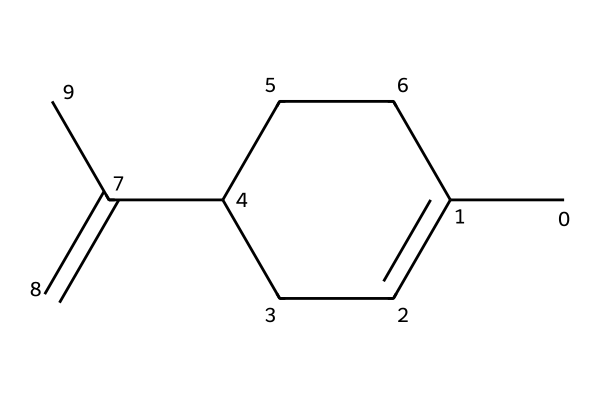What is the molecular formula of limonene? To find the molecular formula, we count the number of carbon and hydrogen atoms in the structure represented by the SMILES. There are 10 carbon atoms (C) and 16 hydrogen atoms (H), giving us the formula C10H16.
Answer: C10H16 How many chiral centers does limonene have? A chiral center is typically a carbon atom bonded to four different substituents. In limonene, there are two such carbon atoms identified in the structure, resulting in two chiral centers.
Answer: 2 What scents are associated with the enantiomers of limonene? Limonene exists in two enantiomeric forms: (R)-limonene has a citrus scent, while (S)-limonene has a pine scent. We infer this from the known aromas associated with the two forms.
Answer: citrus and pine Which enantiomer of limonene is primarily found in citrus fruits? Common knowledge indicates that the (R)-enantiomer of limonene is predominantly available in citrus fruits like oranges and lemons. This is established through studies on the natural sources of limonene.
Answer: R-limonene How many rings are present in the structure of limonene? In the provided SMILES representation, we identify that there is one carbon ring present, as indicated by the number '1' that denotes the start and end of a ring structure.
Answer: 1 What type of compound is limonene classified as? Limonene is classified as a monoterpene, based on its structure that features a combination of cyclic and acyclic components common to terpenes. This classification can be derived from its chemical structure.
Answer: monoterpene 